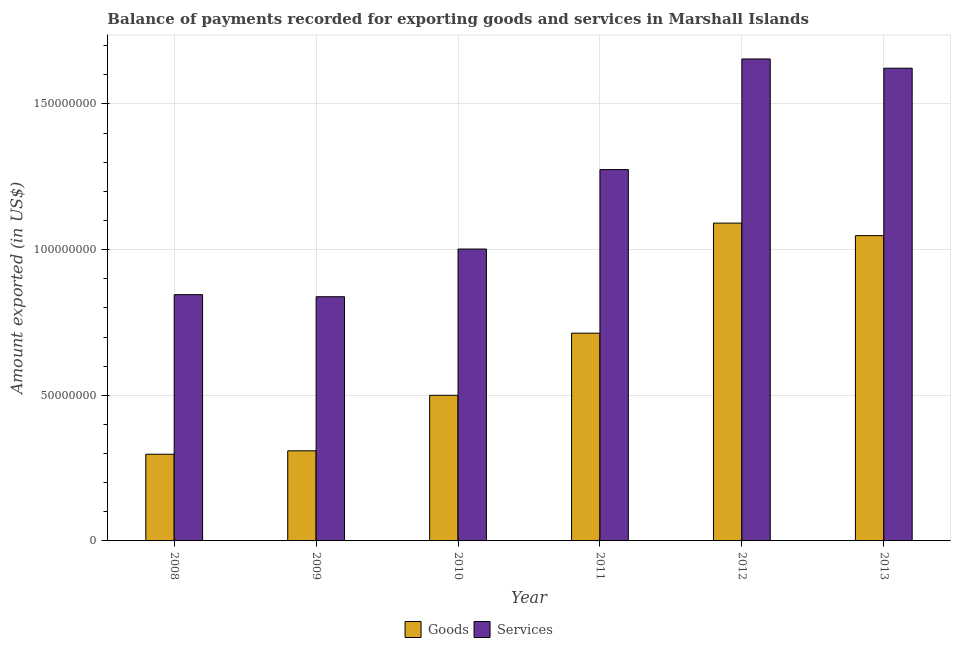How many bars are there on the 6th tick from the left?
Offer a very short reply. 2. In how many cases, is the number of bars for a given year not equal to the number of legend labels?
Your answer should be very brief. 0. What is the amount of services exported in 2010?
Give a very brief answer. 1.00e+08. Across all years, what is the maximum amount of services exported?
Provide a short and direct response. 1.65e+08. Across all years, what is the minimum amount of goods exported?
Keep it short and to the point. 2.98e+07. What is the total amount of goods exported in the graph?
Provide a short and direct response. 3.96e+08. What is the difference between the amount of goods exported in 2009 and that in 2013?
Your answer should be compact. -7.39e+07. What is the difference between the amount of services exported in 2013 and the amount of goods exported in 2009?
Ensure brevity in your answer.  7.84e+07. What is the average amount of goods exported per year?
Offer a very short reply. 6.60e+07. In the year 2009, what is the difference between the amount of services exported and amount of goods exported?
Provide a succinct answer. 0. In how many years, is the amount of services exported greater than 10000000 US$?
Make the answer very short. 6. What is the ratio of the amount of goods exported in 2010 to that in 2013?
Give a very brief answer. 0.48. What is the difference between the highest and the second highest amount of services exported?
Offer a very short reply. 3.17e+06. What is the difference between the highest and the lowest amount of services exported?
Keep it short and to the point. 8.16e+07. In how many years, is the amount of goods exported greater than the average amount of goods exported taken over all years?
Make the answer very short. 3. Is the sum of the amount of goods exported in 2008 and 2009 greater than the maximum amount of services exported across all years?
Provide a short and direct response. No. What does the 1st bar from the left in 2009 represents?
Give a very brief answer. Goods. What does the 1st bar from the right in 2009 represents?
Your answer should be compact. Services. How many bars are there?
Provide a succinct answer. 12. How many years are there in the graph?
Provide a succinct answer. 6. What is the difference between two consecutive major ticks on the Y-axis?
Offer a terse response. 5.00e+07. Does the graph contain any zero values?
Offer a very short reply. No. How many legend labels are there?
Keep it short and to the point. 2. What is the title of the graph?
Provide a short and direct response. Balance of payments recorded for exporting goods and services in Marshall Islands. What is the label or title of the X-axis?
Your answer should be very brief. Year. What is the label or title of the Y-axis?
Offer a terse response. Amount exported (in US$). What is the Amount exported (in US$) in Goods in 2008?
Your answer should be very brief. 2.98e+07. What is the Amount exported (in US$) of Services in 2008?
Provide a succinct answer. 8.45e+07. What is the Amount exported (in US$) in Goods in 2009?
Offer a very short reply. 3.09e+07. What is the Amount exported (in US$) of Services in 2009?
Give a very brief answer. 8.38e+07. What is the Amount exported (in US$) in Goods in 2010?
Offer a terse response. 5.00e+07. What is the Amount exported (in US$) in Services in 2010?
Offer a terse response. 1.00e+08. What is the Amount exported (in US$) in Goods in 2011?
Your answer should be compact. 7.13e+07. What is the Amount exported (in US$) of Services in 2011?
Your response must be concise. 1.27e+08. What is the Amount exported (in US$) of Goods in 2012?
Your response must be concise. 1.09e+08. What is the Amount exported (in US$) in Services in 2012?
Offer a very short reply. 1.65e+08. What is the Amount exported (in US$) in Goods in 2013?
Your response must be concise. 1.05e+08. What is the Amount exported (in US$) in Services in 2013?
Your answer should be compact. 1.62e+08. Across all years, what is the maximum Amount exported (in US$) of Goods?
Provide a succinct answer. 1.09e+08. Across all years, what is the maximum Amount exported (in US$) in Services?
Keep it short and to the point. 1.65e+08. Across all years, what is the minimum Amount exported (in US$) in Goods?
Make the answer very short. 2.98e+07. Across all years, what is the minimum Amount exported (in US$) of Services?
Make the answer very short. 8.38e+07. What is the total Amount exported (in US$) in Goods in the graph?
Your answer should be very brief. 3.96e+08. What is the total Amount exported (in US$) in Services in the graph?
Provide a succinct answer. 7.24e+08. What is the difference between the Amount exported (in US$) of Goods in 2008 and that in 2009?
Your answer should be very brief. -1.17e+06. What is the difference between the Amount exported (in US$) of Services in 2008 and that in 2009?
Ensure brevity in your answer.  7.06e+05. What is the difference between the Amount exported (in US$) in Goods in 2008 and that in 2010?
Ensure brevity in your answer.  -2.02e+07. What is the difference between the Amount exported (in US$) in Services in 2008 and that in 2010?
Give a very brief answer. -1.57e+07. What is the difference between the Amount exported (in US$) in Goods in 2008 and that in 2011?
Provide a succinct answer. -4.16e+07. What is the difference between the Amount exported (in US$) of Services in 2008 and that in 2011?
Your response must be concise. -4.29e+07. What is the difference between the Amount exported (in US$) in Goods in 2008 and that in 2012?
Provide a short and direct response. -7.93e+07. What is the difference between the Amount exported (in US$) in Services in 2008 and that in 2012?
Provide a short and direct response. -8.09e+07. What is the difference between the Amount exported (in US$) of Goods in 2008 and that in 2013?
Ensure brevity in your answer.  -7.50e+07. What is the difference between the Amount exported (in US$) of Services in 2008 and that in 2013?
Ensure brevity in your answer.  -7.77e+07. What is the difference between the Amount exported (in US$) in Goods in 2009 and that in 2010?
Make the answer very short. -1.91e+07. What is the difference between the Amount exported (in US$) of Services in 2009 and that in 2010?
Provide a succinct answer. -1.64e+07. What is the difference between the Amount exported (in US$) of Goods in 2009 and that in 2011?
Keep it short and to the point. -4.04e+07. What is the difference between the Amount exported (in US$) in Services in 2009 and that in 2011?
Offer a very short reply. -4.36e+07. What is the difference between the Amount exported (in US$) in Goods in 2009 and that in 2012?
Offer a terse response. -7.82e+07. What is the difference between the Amount exported (in US$) in Services in 2009 and that in 2012?
Your answer should be compact. -8.16e+07. What is the difference between the Amount exported (in US$) of Goods in 2009 and that in 2013?
Offer a terse response. -7.39e+07. What is the difference between the Amount exported (in US$) in Services in 2009 and that in 2013?
Your answer should be very brief. -7.84e+07. What is the difference between the Amount exported (in US$) of Goods in 2010 and that in 2011?
Make the answer very short. -2.13e+07. What is the difference between the Amount exported (in US$) in Services in 2010 and that in 2011?
Provide a succinct answer. -2.73e+07. What is the difference between the Amount exported (in US$) in Goods in 2010 and that in 2012?
Give a very brief answer. -5.91e+07. What is the difference between the Amount exported (in US$) in Services in 2010 and that in 2012?
Your answer should be very brief. -6.52e+07. What is the difference between the Amount exported (in US$) of Goods in 2010 and that in 2013?
Offer a very short reply. -5.48e+07. What is the difference between the Amount exported (in US$) of Services in 2010 and that in 2013?
Your answer should be very brief. -6.21e+07. What is the difference between the Amount exported (in US$) of Goods in 2011 and that in 2012?
Provide a short and direct response. -3.78e+07. What is the difference between the Amount exported (in US$) in Services in 2011 and that in 2012?
Provide a succinct answer. -3.80e+07. What is the difference between the Amount exported (in US$) of Goods in 2011 and that in 2013?
Your answer should be very brief. -3.35e+07. What is the difference between the Amount exported (in US$) in Services in 2011 and that in 2013?
Provide a short and direct response. -3.48e+07. What is the difference between the Amount exported (in US$) in Goods in 2012 and that in 2013?
Provide a short and direct response. 4.31e+06. What is the difference between the Amount exported (in US$) in Services in 2012 and that in 2013?
Offer a very short reply. 3.17e+06. What is the difference between the Amount exported (in US$) in Goods in 2008 and the Amount exported (in US$) in Services in 2009?
Offer a very short reply. -5.41e+07. What is the difference between the Amount exported (in US$) in Goods in 2008 and the Amount exported (in US$) in Services in 2010?
Provide a short and direct response. -7.04e+07. What is the difference between the Amount exported (in US$) of Goods in 2008 and the Amount exported (in US$) of Services in 2011?
Your response must be concise. -9.77e+07. What is the difference between the Amount exported (in US$) in Goods in 2008 and the Amount exported (in US$) in Services in 2012?
Provide a succinct answer. -1.36e+08. What is the difference between the Amount exported (in US$) of Goods in 2008 and the Amount exported (in US$) of Services in 2013?
Offer a terse response. -1.33e+08. What is the difference between the Amount exported (in US$) of Goods in 2009 and the Amount exported (in US$) of Services in 2010?
Your response must be concise. -6.93e+07. What is the difference between the Amount exported (in US$) in Goods in 2009 and the Amount exported (in US$) in Services in 2011?
Your answer should be compact. -9.65e+07. What is the difference between the Amount exported (in US$) of Goods in 2009 and the Amount exported (in US$) of Services in 2012?
Provide a succinct answer. -1.35e+08. What is the difference between the Amount exported (in US$) of Goods in 2009 and the Amount exported (in US$) of Services in 2013?
Provide a short and direct response. -1.31e+08. What is the difference between the Amount exported (in US$) in Goods in 2010 and the Amount exported (in US$) in Services in 2011?
Offer a terse response. -7.75e+07. What is the difference between the Amount exported (in US$) in Goods in 2010 and the Amount exported (in US$) in Services in 2012?
Make the answer very short. -1.15e+08. What is the difference between the Amount exported (in US$) of Goods in 2010 and the Amount exported (in US$) of Services in 2013?
Provide a succinct answer. -1.12e+08. What is the difference between the Amount exported (in US$) in Goods in 2011 and the Amount exported (in US$) in Services in 2012?
Provide a succinct answer. -9.41e+07. What is the difference between the Amount exported (in US$) of Goods in 2011 and the Amount exported (in US$) of Services in 2013?
Provide a short and direct response. -9.09e+07. What is the difference between the Amount exported (in US$) of Goods in 2012 and the Amount exported (in US$) of Services in 2013?
Keep it short and to the point. -5.32e+07. What is the average Amount exported (in US$) in Goods per year?
Offer a terse response. 6.60e+07. What is the average Amount exported (in US$) of Services per year?
Your answer should be compact. 1.21e+08. In the year 2008, what is the difference between the Amount exported (in US$) of Goods and Amount exported (in US$) of Services?
Your answer should be very brief. -5.48e+07. In the year 2009, what is the difference between the Amount exported (in US$) of Goods and Amount exported (in US$) of Services?
Give a very brief answer. -5.29e+07. In the year 2010, what is the difference between the Amount exported (in US$) in Goods and Amount exported (in US$) in Services?
Offer a very short reply. -5.02e+07. In the year 2011, what is the difference between the Amount exported (in US$) in Goods and Amount exported (in US$) in Services?
Offer a terse response. -5.61e+07. In the year 2012, what is the difference between the Amount exported (in US$) of Goods and Amount exported (in US$) of Services?
Give a very brief answer. -5.63e+07. In the year 2013, what is the difference between the Amount exported (in US$) in Goods and Amount exported (in US$) in Services?
Provide a short and direct response. -5.75e+07. What is the ratio of the Amount exported (in US$) in Goods in 2008 to that in 2009?
Make the answer very short. 0.96. What is the ratio of the Amount exported (in US$) of Services in 2008 to that in 2009?
Provide a succinct answer. 1.01. What is the ratio of the Amount exported (in US$) of Goods in 2008 to that in 2010?
Ensure brevity in your answer.  0.6. What is the ratio of the Amount exported (in US$) of Services in 2008 to that in 2010?
Keep it short and to the point. 0.84. What is the ratio of the Amount exported (in US$) of Goods in 2008 to that in 2011?
Ensure brevity in your answer.  0.42. What is the ratio of the Amount exported (in US$) of Services in 2008 to that in 2011?
Your answer should be compact. 0.66. What is the ratio of the Amount exported (in US$) of Goods in 2008 to that in 2012?
Provide a succinct answer. 0.27. What is the ratio of the Amount exported (in US$) in Services in 2008 to that in 2012?
Give a very brief answer. 0.51. What is the ratio of the Amount exported (in US$) in Goods in 2008 to that in 2013?
Provide a short and direct response. 0.28. What is the ratio of the Amount exported (in US$) in Services in 2008 to that in 2013?
Your answer should be very brief. 0.52. What is the ratio of the Amount exported (in US$) in Goods in 2009 to that in 2010?
Keep it short and to the point. 0.62. What is the ratio of the Amount exported (in US$) in Services in 2009 to that in 2010?
Offer a terse response. 0.84. What is the ratio of the Amount exported (in US$) of Goods in 2009 to that in 2011?
Your answer should be compact. 0.43. What is the ratio of the Amount exported (in US$) in Services in 2009 to that in 2011?
Your answer should be very brief. 0.66. What is the ratio of the Amount exported (in US$) in Goods in 2009 to that in 2012?
Offer a very short reply. 0.28. What is the ratio of the Amount exported (in US$) of Services in 2009 to that in 2012?
Make the answer very short. 0.51. What is the ratio of the Amount exported (in US$) of Goods in 2009 to that in 2013?
Keep it short and to the point. 0.3. What is the ratio of the Amount exported (in US$) of Services in 2009 to that in 2013?
Provide a short and direct response. 0.52. What is the ratio of the Amount exported (in US$) of Goods in 2010 to that in 2011?
Your answer should be very brief. 0.7. What is the ratio of the Amount exported (in US$) in Services in 2010 to that in 2011?
Keep it short and to the point. 0.79. What is the ratio of the Amount exported (in US$) in Goods in 2010 to that in 2012?
Make the answer very short. 0.46. What is the ratio of the Amount exported (in US$) in Services in 2010 to that in 2012?
Your response must be concise. 0.61. What is the ratio of the Amount exported (in US$) of Goods in 2010 to that in 2013?
Provide a short and direct response. 0.48. What is the ratio of the Amount exported (in US$) in Services in 2010 to that in 2013?
Provide a short and direct response. 0.62. What is the ratio of the Amount exported (in US$) of Goods in 2011 to that in 2012?
Ensure brevity in your answer.  0.65. What is the ratio of the Amount exported (in US$) of Services in 2011 to that in 2012?
Provide a short and direct response. 0.77. What is the ratio of the Amount exported (in US$) of Goods in 2011 to that in 2013?
Provide a short and direct response. 0.68. What is the ratio of the Amount exported (in US$) of Services in 2011 to that in 2013?
Your answer should be very brief. 0.79. What is the ratio of the Amount exported (in US$) in Goods in 2012 to that in 2013?
Your answer should be very brief. 1.04. What is the ratio of the Amount exported (in US$) in Services in 2012 to that in 2013?
Offer a terse response. 1.02. What is the difference between the highest and the second highest Amount exported (in US$) of Goods?
Offer a very short reply. 4.31e+06. What is the difference between the highest and the second highest Amount exported (in US$) in Services?
Ensure brevity in your answer.  3.17e+06. What is the difference between the highest and the lowest Amount exported (in US$) in Goods?
Provide a short and direct response. 7.93e+07. What is the difference between the highest and the lowest Amount exported (in US$) in Services?
Ensure brevity in your answer.  8.16e+07. 